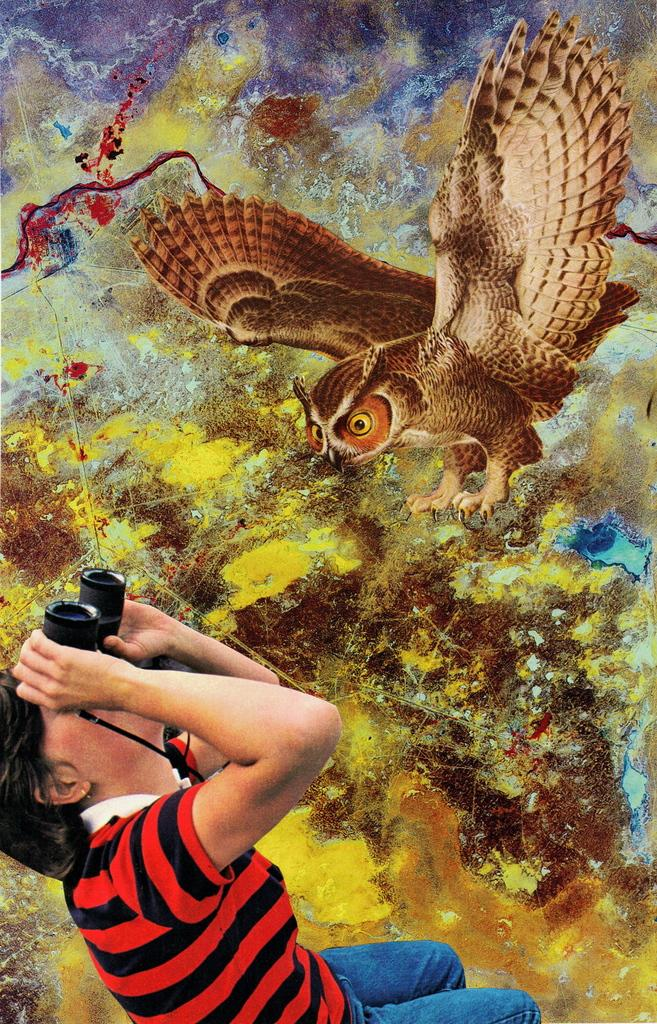What is the man in the image doing? The man is standing in the image. What is the man holding in his hands? The man is holding binoculars in his hands. What can be seen on the wall in the image? There is a painting of an owl on the wall in the image. What type of steam is coming out of the man's ears in the image? There is no steam coming out of the man's ears in the image; he is simply holding binoculars. 